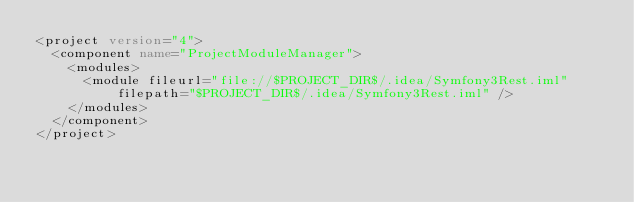Convert code to text. <code><loc_0><loc_0><loc_500><loc_500><_XML_><project version="4">
  <component name="ProjectModuleManager">
    <modules>
      <module fileurl="file://$PROJECT_DIR$/.idea/Symfony3Rest.iml" filepath="$PROJECT_DIR$/.idea/Symfony3Rest.iml" />
    </modules>
  </component>
</project></code> 